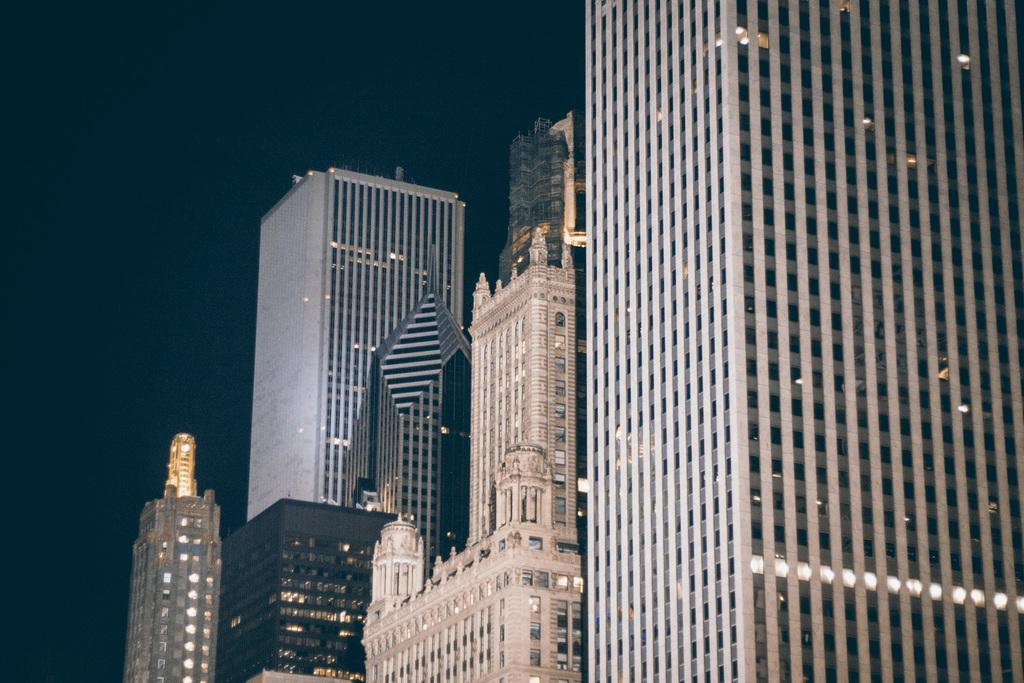What is the main subject of the image? The main subject of the image is a group of buildings. What specific features can be observed on the buildings? The buildings have windows. What else is visible in the image besides the buildings? There are lights visible in the image. What is visible in the background of the image? The sky is visible in the image. What type of club can be seen in the image? There is no club present in the image; it features a group of buildings. What arm is visible in the image? There are no arms visible in the image; it features a group of buildings. 